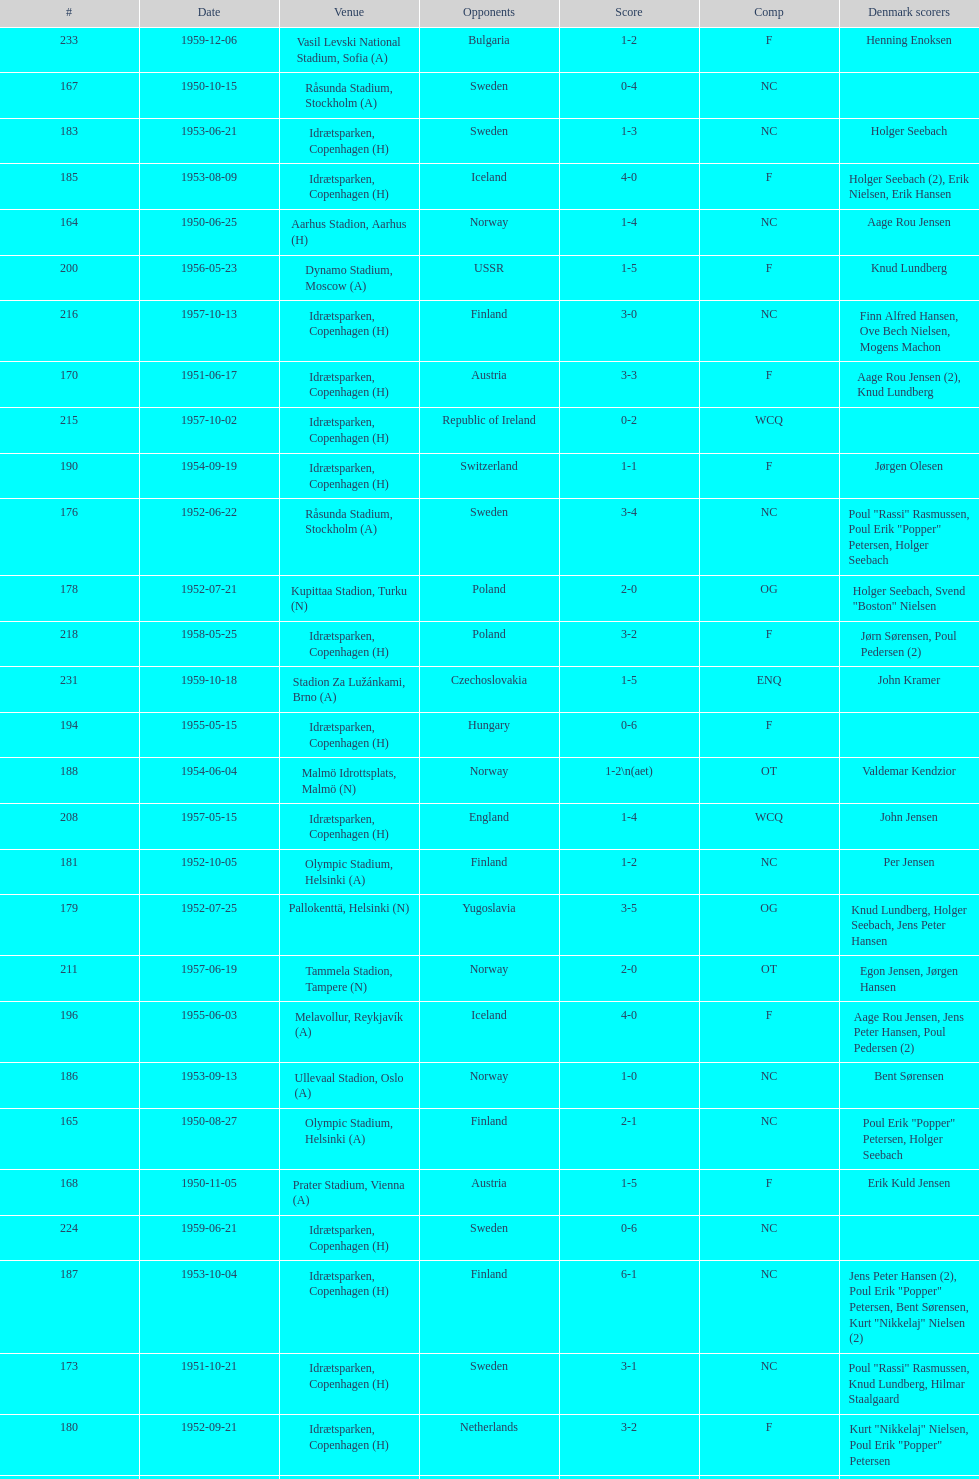Can you parse all the data within this table? {'header': ['#', 'Date', 'Venue', 'Opponents', 'Score', 'Comp', 'Denmark scorers'], 'rows': [['233', '1959-12-06', 'Vasil Levski National Stadium, Sofia (A)', 'Bulgaria', '1-2', 'F', 'Henning Enoksen'], ['167', '1950-10-15', 'Råsunda Stadium, Stockholm (A)', 'Sweden', '0-4', 'NC', ''], ['183', '1953-06-21', 'Idrætsparken, Copenhagen (H)', 'Sweden', '1-3', 'NC', 'Holger Seebach'], ['185', '1953-08-09', 'Idrætsparken, Copenhagen (H)', 'Iceland', '4-0', 'F', 'Holger Seebach (2), Erik Nielsen, Erik Hansen'], ['164', '1950-06-25', 'Aarhus Stadion, Aarhus (H)', 'Norway', '1-4', 'NC', 'Aage Rou Jensen'], ['200', '1956-05-23', 'Dynamo Stadium, Moscow (A)', 'USSR', '1-5', 'F', 'Knud Lundberg'], ['216', '1957-10-13', 'Idrætsparken, Copenhagen (H)', 'Finland', '3-0', 'NC', 'Finn Alfred Hansen, Ove Bech Nielsen, Mogens Machon'], ['170', '1951-06-17', 'Idrætsparken, Copenhagen (H)', 'Austria', '3-3', 'F', 'Aage Rou Jensen (2), Knud Lundberg'], ['215', '1957-10-02', 'Idrætsparken, Copenhagen (H)', 'Republic of Ireland', '0-2', 'WCQ', ''], ['190', '1954-09-19', 'Idrætsparken, Copenhagen (H)', 'Switzerland', '1-1', 'F', 'Jørgen Olesen'], ['176', '1952-06-22', 'Råsunda Stadium, Stockholm (A)', 'Sweden', '3-4', 'NC', 'Poul "Rassi" Rasmussen, Poul Erik "Popper" Petersen, Holger Seebach'], ['178', '1952-07-21', 'Kupittaa Stadion, Turku (N)', 'Poland', '2-0', 'OG', 'Holger Seebach, Svend "Boston" Nielsen'], ['218', '1958-05-25', 'Idrætsparken, Copenhagen (H)', 'Poland', '3-2', 'F', 'Jørn Sørensen, Poul Pedersen (2)'], ['231', '1959-10-18', 'Stadion Za Lužánkami, Brno (A)', 'Czechoslovakia', '1-5', 'ENQ', 'John Kramer'], ['194', '1955-05-15', 'Idrætsparken, Copenhagen (H)', 'Hungary', '0-6', 'F', ''], ['188', '1954-06-04', 'Malmö Idrottsplats, Malmö (N)', 'Norway', '1-2\\n(aet)', 'OT', 'Valdemar Kendzior'], ['208', '1957-05-15', 'Idrætsparken, Copenhagen (H)', 'England', '1-4', 'WCQ', 'John Jensen'], ['181', '1952-10-05', 'Olympic Stadium, Helsinki (A)', 'Finland', '1-2', 'NC', 'Per Jensen'], ['179', '1952-07-25', 'Pallokenttä, Helsinki (N)', 'Yugoslavia', '3-5', 'OG', 'Knud Lundberg, Holger Seebach, Jens Peter Hansen'], ['211', '1957-06-19', 'Tammela Stadion, Tampere (N)', 'Norway', '2-0', 'OT', 'Egon Jensen, Jørgen Hansen'], ['196', '1955-06-03', 'Melavollur, Reykjavík (A)', 'Iceland', '4-0', 'F', 'Aage Rou Jensen, Jens Peter Hansen, Poul Pedersen (2)'], ['186', '1953-09-13', 'Ullevaal Stadion, Oslo (A)', 'Norway', '1-0', 'NC', 'Bent Sørensen'], ['165', '1950-08-27', 'Olympic Stadium, Helsinki (A)', 'Finland', '2-1', 'NC', 'Poul Erik "Popper" Petersen, Holger Seebach'], ['168', '1950-11-05', 'Prater Stadium, Vienna (A)', 'Austria', '1-5', 'F', 'Erik Kuld Jensen'], ['224', '1959-06-21', 'Idrætsparken, Copenhagen (H)', 'Sweden', '0-6', 'NC', ''], ['187', '1953-10-04', 'Idrætsparken, Copenhagen (H)', 'Finland', '6-1', 'NC', 'Jens Peter Hansen (2), Poul Erik "Popper" Petersen, Bent Sørensen, Kurt "Nikkelaj" Nielsen (2)'], ['173', '1951-10-21', 'Idrætsparken, Copenhagen (H)', 'Sweden', '3-1', 'NC', 'Poul "Rassi" Rasmussen, Knud Lundberg, Hilmar Staalgaard'], ['180', '1952-09-21', 'Idrætsparken, Copenhagen (H)', 'Netherlands', '3-2', 'F', 'Kurt "Nikkelaj" Nielsen, Poul Erik "Popper" Petersen'], ['227', '1959-08-18', 'Idrætsparken, Copenhagen (H)', 'Iceland', '1-1', 'OGQ', 'Henning Enoksen'], ['232', '1959-12-02', 'Olympic Stadium, Athens (A)', 'Greece', '3-1', 'F', 'Henning Enoksen (2), Poul Pedersen'], ['169', '1951-05-12', 'Hampden Park, Glasgow (A)', 'Scotland', '1-3', 'F', 'Jørgen W. Hansen'], ['226', '1959-07-02', 'Idrætsparken, Copenhagen (H)', 'Norway', '2-1', 'OGQ', 'Henning Enoksen, Ole Madsen'], ['212', '1957-06-30', 'Idrætsparken, Copenhagen (H)', 'Sweden', '1-2', 'NC', 'Jens Peter Hansen'], ['172', '1951-09-30', 'Idrætsparken, Copenhagen (H)', 'Finland', '1-0', 'NC', 'Hilmar Staalgaard'], ['206', '1956-11-04', 'Idrætsparken, Copenhagen (H)', 'Netherlands', '2-2', 'F', 'Jørgen Olesen, Knud Lundberg'], ['220', '1958-09-14', 'Olympic Stadium, Helsinki (A)', 'Finland', '4-1', 'NC', 'Poul Pedersen, Mogens Machon, John Danielsen (2)'], ['175', '1952-06-11', 'Bislett Stadium, Oslo (N)', 'Sweden', '0-2', 'OT', ''], ['214', '1957-09-22', 'Ullevaal Stadion, Oslo (A)', 'Norway', '2-2', 'NC', 'Poul Pedersen, Peder Kjær'], ['163', '1950-06-22', 'Idrætsparken, Copenhagen (H)', 'Norway', '4-0', 'NC', 'Poul Erik "Popper" Petersen, Edwin Hansen, Jens Peter Hansen, Aage Rou Jensen'], ['171', '1951-09-16', 'Ullevaal Stadion, Oslo (A)', 'Norway', '0-2', 'NC', ''], ['182', '1952-10-19', 'Idrætsparken, Copenhagen (H)', 'Norway', '1-3', 'NC', 'Per Jensen'], ['207', '1956-12-05', 'Molineux, Wolverhampton (A)', 'England', '2-5', 'WCQ', 'Ove Bech Nielsen (2)'], ['191', '1954-10-10', 'Råsunda Stadium, Stockholm (A)', 'Sweden', '2-5', 'NC', 'Jens Peter Hansen, Bent Sørensen'], ['221', '1958-09-24', 'Idrætsparken, Copenhagen (H)', 'West Germany', '1-1', 'F', 'Henning Enoksen'], ['225', '1959-06-26', 'Laugardalsvöllur, Reykjavík (A)', 'Iceland', '4-2', 'OGQ', 'Jens Peter Hansen (2), Ole Madsen (2)'], ['204', '1956-10-03', 'Dalymount Park, Dublin (A)', 'Republic of Ireland', '1-2', 'WCQ', 'Aage Rou Jensen'], ['199', '1955-10-16', 'Idrætsparken, Copenhagen (H)', 'Sweden', '3-3', 'NC', 'Ove Andersen (2), Knud Lundberg'], ['198', '1955-10-02', 'Idrætsparken, Copenhagen (H)', 'England', '1-5', 'NC', 'Knud Lundberg'], ['219', '1958-06-29', 'Idrætsparken, Copenhagen (H)', 'Norway', '1-2', 'NC', 'Poul Pedersen'], ['228', '1959-09-13', 'Ullevaal Stadion, Oslo (A)', 'Norway', '4-2', 'OGQ\\nNC', 'Harald Nielsen, Henning Enoksen (2), Poul Pedersen'], ['174', '1952-05-25', 'Idrætsparken, Copenhagen (H)', 'Scotland', '1-2', 'F', 'Poul "Rassi" Rasmussen'], ['202', '1956-07-01', 'Idrætsparken, Copenhagen (H)', 'USSR', '2-5', 'F', 'Ove Andersen, Aage Rou Jensen'], ['193', '1955-03-13', 'Olympic Stadium, Amsterdam (A)', 'Netherlands', '1-1', 'F', 'Vagn Birkeland'], ['213', '1957-07-10', 'Laugardalsvöllur, Reykjavík (A)', 'Iceland', '6-2', 'OT', 'Egon Jensen (3), Poul Pedersen, Jens Peter Hansen (2)'], ['184', '1953-06-27', 'St. Jakob-Park, Basel (A)', 'Switzerland', '4-1', 'F', 'Knud Ove Sørensen, Aage Rou Jensen (2), Jens Peter Hansen'], ['209', '1957-05-26', 'Idrætsparken, Copenhagen (H)', 'Bulgaria', '1-1', 'F', 'Aage Rou Jensen'], ['166', '1950-09-10', 'Idrætsparken, Copenhagen (H)', 'Yugoslavia', '1-4', 'F', 'Edwin Hansen'], ['223', '1958-10-26', 'Råsunda Stadium, Stockholm (A)', 'Sweden', '4-4', 'NC', 'Ole Madsen (2), Henning Enoksen, Jørn Sørensen'], ['230', '1959-10-04', 'Idrætsparken, Copenhagen (H)', 'Finland', '4-0', 'NC', 'Harald Nielsen (3), John Kramer'], ['189', '1954-06-13', 'Olympic Stadium, Helsinki (A)', 'Finland', '2-2', 'NC', 'Valdemar Kendzior (2)'], ['222', '1958-10-15', 'Idrætsparken, Copenhagen (H)', 'Netherlands', '1-5', 'F', 'Henning Enoksen'], ['177', '1952-07-15', 'Tammela Stadion, Tampere (N)', 'Greece', '2-1', 'OG', 'Poul Erik "Popper" Petersen, Holger Seebach'], ['197', '1955-09-11', 'Ullevaal Stadion, Oslo (A)', 'Norway', '1-1', 'NC', 'Jørgen Jacobsen'], ['217', '1958-05-15', 'Aarhus Stadion, Aarhus (H)', 'Curaçao', '3-2', 'F', 'Poul Pedersen, Henning Enoksen (2)'], ['192', '1954-10-31', 'Idrætsparken, Copenhagen (H)', 'Norway', '0-1', 'NC', ''], ['195', '1955-06-19', 'Idrætsparken, Copenhagen (H)', 'Finland', '2-1', 'NC', 'Jens Peter Hansen (2)'], ['229', '1959-09-23', 'Idrætsparken, Copenhagen (H)', 'Czechoslovakia', '2-2', 'ENQ', 'Poul Pedersen, Bent Hansen'], ['205', '1956-10-21', 'Råsunda Stadium, Stockholm (A)', 'Sweden', '1-1', 'NC', 'Jens Peter Hansen'], ['203', '1956-09-16', 'Olympic Stadium, Helsinki (A)', 'Finland', '4-0', 'NC', 'Poul Pedersen, Jørgen Hansen, Ove Andersen (2)'], ['162', '1950-05-28', 'JNA Stadium, Belgrade (A)', 'Yugoslavia', '1-5', 'F', 'Axel Pilmark'], ['201', '1956-06-24', 'Idrætsparken, Copenhagen (H)', 'Norway', '2-3', 'NC', 'Knud Lundberg, Poul Pedersen'], ['210', '1957-06-18', 'Olympic Stadium, Helsinki (A)', 'Finland', '0-2', 'OT', '']]} Who did they play in the game listed directly above july 25, 1952? Poland. 